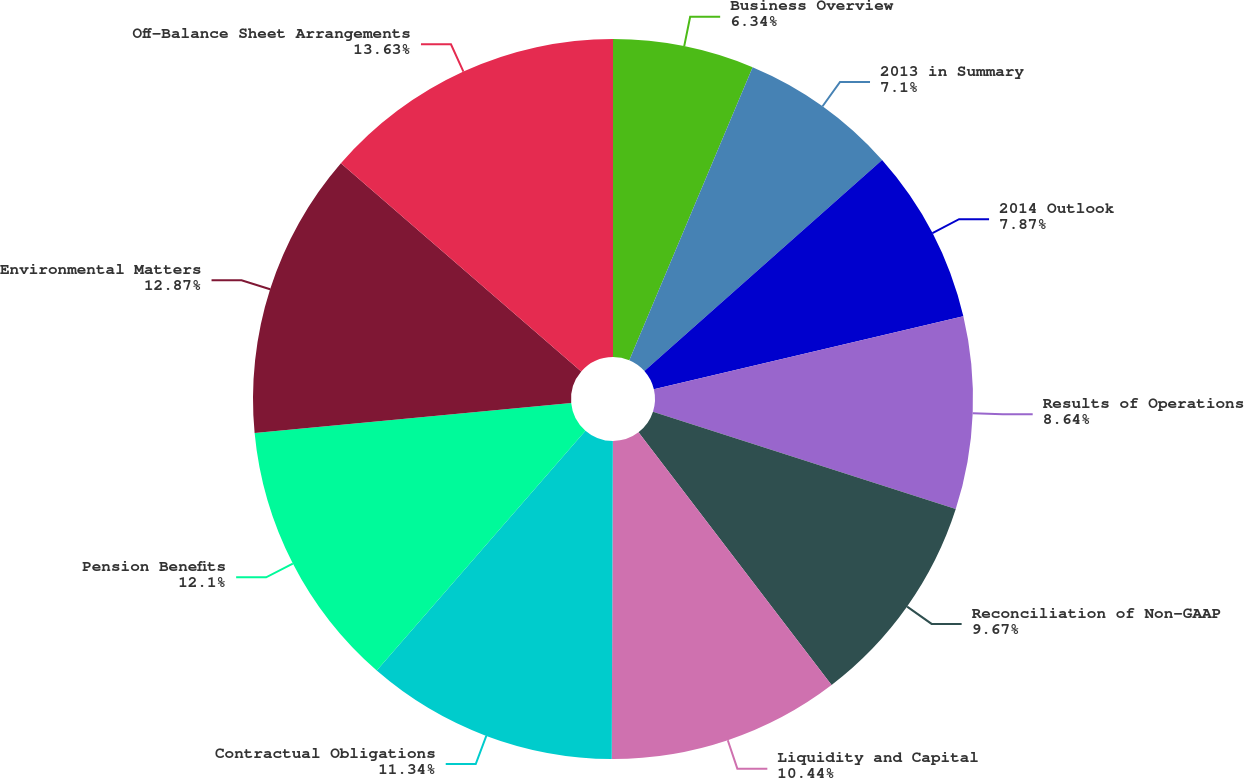Convert chart. <chart><loc_0><loc_0><loc_500><loc_500><pie_chart><fcel>Business Overview<fcel>2013 in Summary<fcel>2014 Outlook<fcel>Results of Operations<fcel>Reconciliation of Non-GAAP<fcel>Liquidity and Capital<fcel>Contractual Obligations<fcel>Pension Benefits<fcel>Environmental Matters<fcel>Off-Balance Sheet Arrangements<nl><fcel>6.34%<fcel>7.1%<fcel>7.87%<fcel>8.64%<fcel>9.67%<fcel>10.44%<fcel>11.34%<fcel>12.1%<fcel>12.87%<fcel>13.64%<nl></chart> 